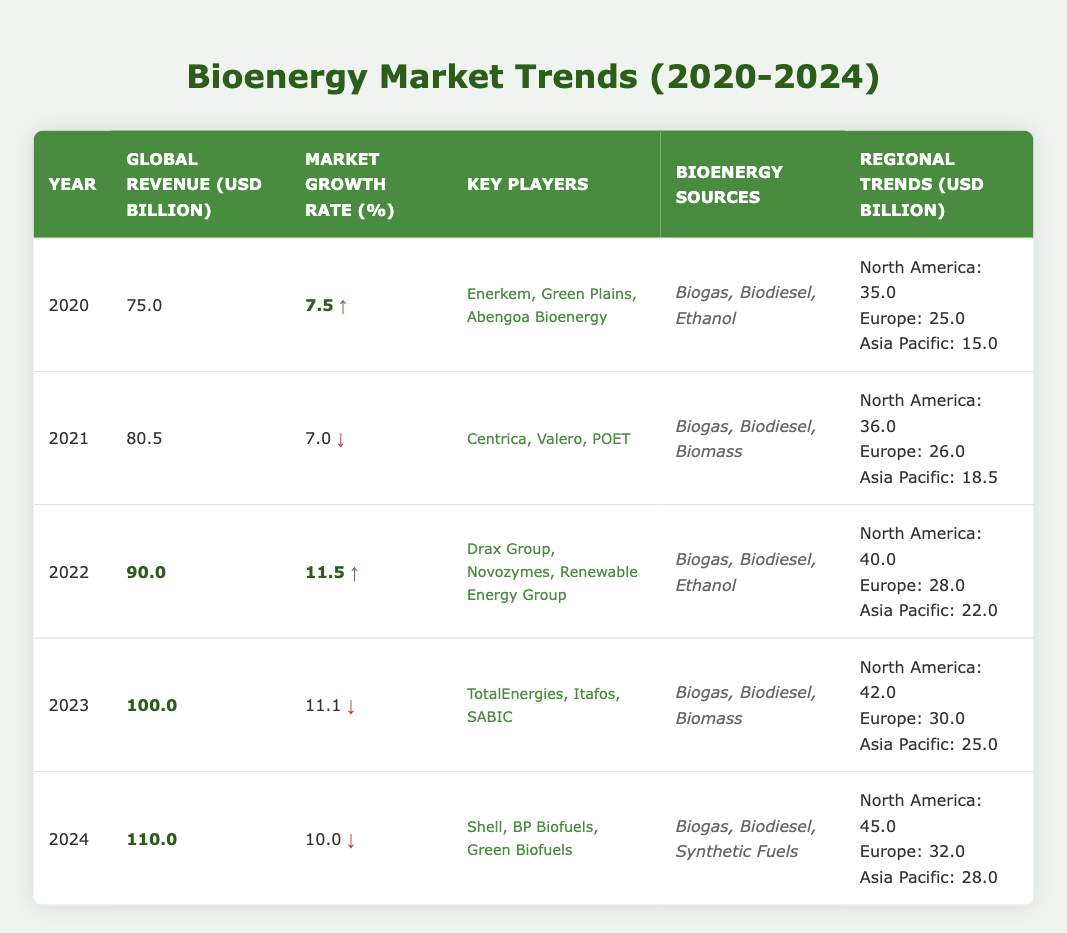What was the global revenue from bioenergy sales in 2022? The table shows that in 2022, the global revenue was recorded as 90.0 USD billion.
Answer: 90.0 USD billion Which year had the highest market growth rate? The highest market growth rate in the table is 11.5%, which occurred in 2022.
Answer: 2022 What are the key players in the bioenergy market in 2023? The table lists the key players for 2023 as TotalEnergies, Itafos, and SABIC.
Answer: TotalEnergies, Itafos, SABIC How much revenue did North America generate from bioenergy in 2024? According to the table, North America generated 45.0 USD billion in 2024.
Answer: 45.0 USD billion What is the total revenue (in billion USD) from bioenergy in 2020 and 2021 combined? The total revenue for 2020 is 75.0 billion and for 2021 is 80.5 billion. Summing these gives 75.0 + 80.5 = 155.5.
Answer: 155.5 USD billion Which year saw a decline in market growth rate compared to the previous year? Comparing the years, 2023 had a market growth rate of 11.1%, which is lower than 11.5% in 2022, indicating a decline.
Answer: 2023 What is the average global revenue from bioenergy sales over the years 2020 to 2024? The revenues for the five years are 75.0, 80.5, 90.0, 100.0, and 110.0 billion. The total sum is 75.0 + 80.5 + 90.0 + 100.0 + 110.0 = 455.5. Dividing by 5 gives an average of 455.5 / 5 = 91.1.
Answer: 91.1 USD billion Does Europe consistently show an increase in bioenergy revenue from 2020 to 2024? To see if Europe shows a consistent increase, we compare the figures: 25.0 (2020), 26.0 (2021), 28.0 (2022), 30.0 (2023), and 32.0 (2024). All values increase, confirming a trend of growth.
Answer: Yes What was the total revenue from bioenergy sales in Asia Pacific across all given years? The revenue from Asia Pacific for the years is: 15.0 (2020) + 18.5 (2021) + 22.0 (2022) + 25.0 (2023) + 28.0 (2024). Adding these gives 15.0 + 18.5 + 22.0 + 25.0 + 28.0 = 108.5 billion.
Answer: 108.5 USD billion Which bioenergy source was listed in every year from 2020 to 2024? By examining the list of bioenergy sources for each year, "Biogas" appears in every year: 2020, 2021, 2022, 2023, and 2024.
Answer: Biogas 